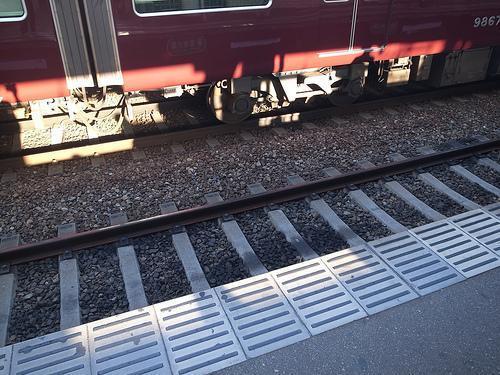How many trains are in the picture?
Give a very brief answer. 1. How many windows are on the train?
Give a very brief answer. 2. How many people are shown?
Give a very brief answer. 0. 